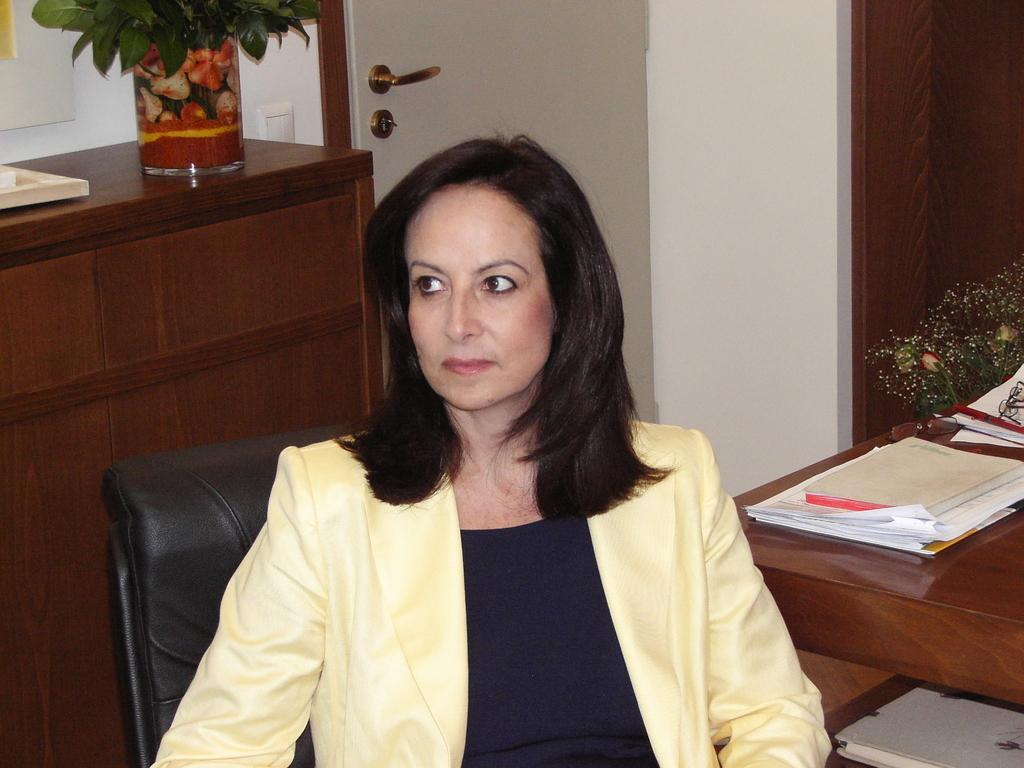What is one of the main structures in the image? There is a door in the image. What is another structure present in the image? There is a wall in the image. What is the woman in the image doing? The woman is sitting on a chair in the image. What is on the table in the image? There are books and papers on the table in the image. What type of ornament is hanging from the door in the image? There is no ornament hanging from the door in the image. How much does the woman's friend weigh in the image? There is no friend present in the image, so their weight cannot be determined. 